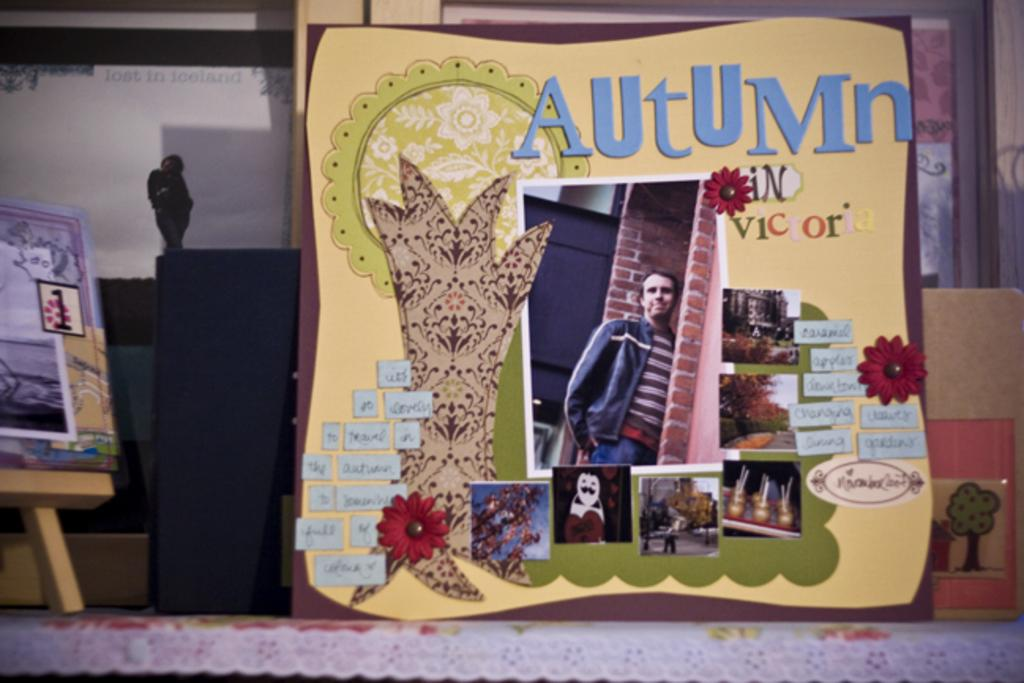<image>
Provide a brief description of the given image. A picture frame with the words "Autumn in Victoria" written on it. 